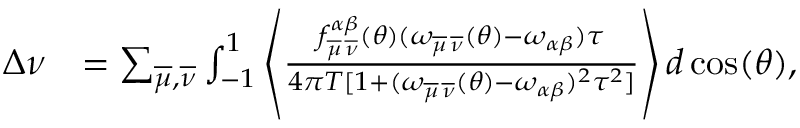Convert formula to latex. <formula><loc_0><loc_0><loc_500><loc_500>\begin{array} { r l } { \Delta \nu } & { = \sum _ { \overline { \mu } , \overline { \nu } } \int _ { - 1 } ^ { 1 } \left \langle \frac { f _ { \overline { \mu } \, \overline { \nu } } ^ { \alpha \beta } ( \theta ) ( \omega _ { \overline { \mu } \, \overline { \nu } } ( \theta ) - \omega _ { \alpha \beta } ) \tau } { 4 \pi T [ 1 + ( \omega _ { \overline { \mu } \, \overline { \nu } } ( \theta ) - \omega _ { \alpha \beta } ) ^ { 2 } \tau ^ { 2 } ] } \right \rangle d \cos ( \theta ) , } \end{array}</formula> 